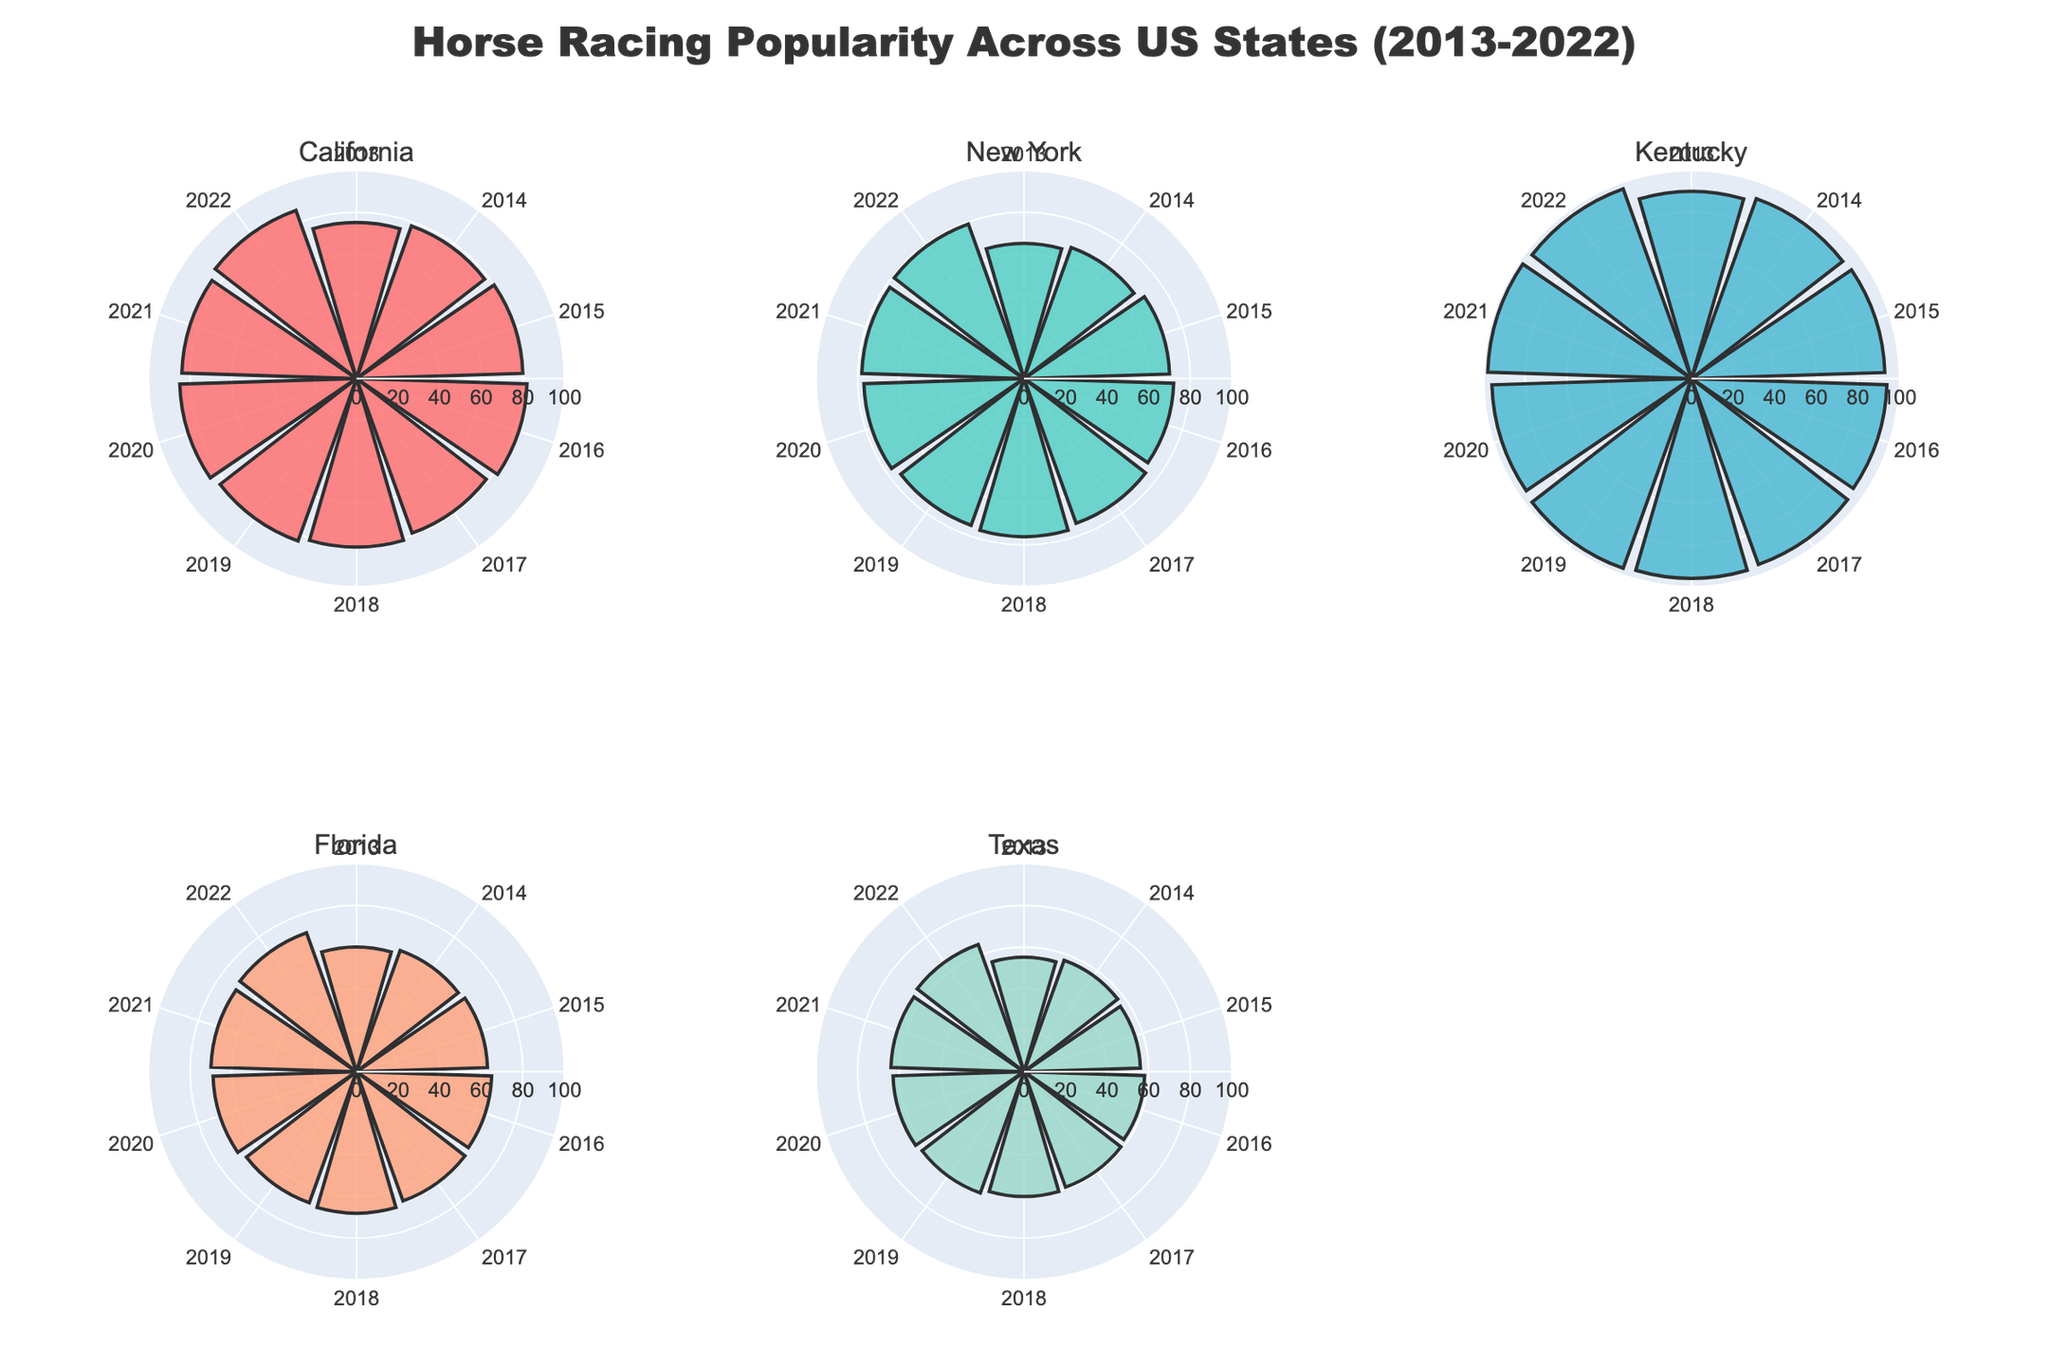What is the title of the plot? The title of the plot is located at the top center of the figure and is bolded. It reads "Horse Racing Popularity Across US States (2013-2022)".
Answer: Horse Racing Popularity Across US States (2013-2022) How does the popularity of horse racing in Texas change from 2013 to 2022? The plot shows the popularity values for each year in a circular layout. For Texas, the values increase gradually from 55 in 2013 to 65 in 2022.
Answer: It increases Which state had the highest popularity in horse racing in 2022? To find the state with the highest popularity in 2022, we look at the outermost values in each subplot. Kentucky's bar reaches the highest radial distance with a value of 97.
Answer: Kentucky Compare the popularity trends of horse racing in California and New York over the decade. California and New York both show increasing trends in their subplots. For California, it starts at 75 in 2013 and reaches 86 in 2022. For New York, it starts at 65 in 2013 and reaches 79 in 2022. Both exhibit an upward trend, but California has higher values throughout.
Answer: Both upward, California higher In which year did horse racing popularity peak in Kentucky? By observing the radial distances in Kentucky's subplot, we see that the highest value is in 2021 with a popularity of 98.
Answer: 2021 What is the average popularity of horse racing in Florida for the years 2019-2022? Sum the popularity values for the years 2019 (67), 2020 (69), 2021 (70), and 2022 (71) and divide by the number of years (4). (67 + 69 + 70 + 71) / 4 = 277 / 4 = 69.25
Answer: 69.25 Which state shows the least variation in horse racing popularity over the decade? To determine this, we observe the subplots and compare the range of values (max - min) for each state. Texas shows the least variation, with values ranging from 55 to 65, a difference of 10.
Answer: Texas How does horse racing popularity in New York in 2018 compare to Texas in 2018? From the subplots, New York's popularity in 2018 is 76, while Texas's popularity in 2018 is 60. New York's popularity is higher than Texas's.
Answer: New York is higher What is the trend of horse racing popularity in California between 2019 and 2021? In California's subplot, the popularity values from 2019 to 2021 are 83, 85, and 84, respectively. It increases from 83 to 85 between 2019 and 2020, then slightly decreases to 84 in 2021.
Answer: Increases then slightly decreases 